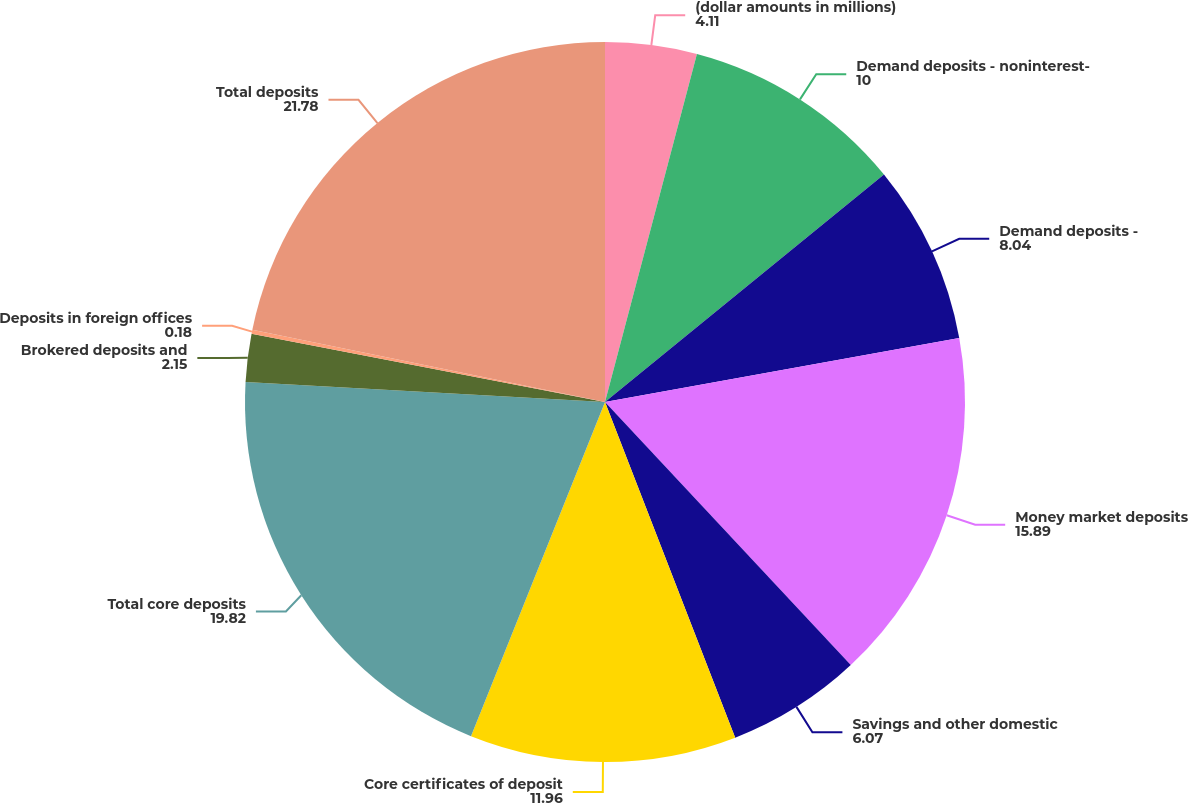<chart> <loc_0><loc_0><loc_500><loc_500><pie_chart><fcel>(dollar amounts in millions)<fcel>Demand deposits - noninterest-<fcel>Demand deposits -<fcel>Money market deposits<fcel>Savings and other domestic<fcel>Core certificates of deposit<fcel>Total core deposits<fcel>Brokered deposits and<fcel>Deposits in foreign offices<fcel>Total deposits<nl><fcel>4.11%<fcel>10.0%<fcel>8.04%<fcel>15.89%<fcel>6.07%<fcel>11.96%<fcel>19.82%<fcel>2.15%<fcel>0.18%<fcel>21.78%<nl></chart> 